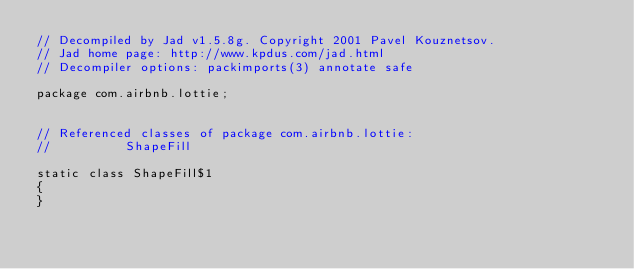<code> <loc_0><loc_0><loc_500><loc_500><_Java_>// Decompiled by Jad v1.5.8g. Copyright 2001 Pavel Kouznetsov.
// Jad home page: http://www.kpdus.com/jad.html
// Decompiler options: packimports(3) annotate safe 

package com.airbnb.lottie;


// Referenced classes of package com.airbnb.lottie:
//			ShapeFill

static class ShapeFill$1
{
}
</code> 